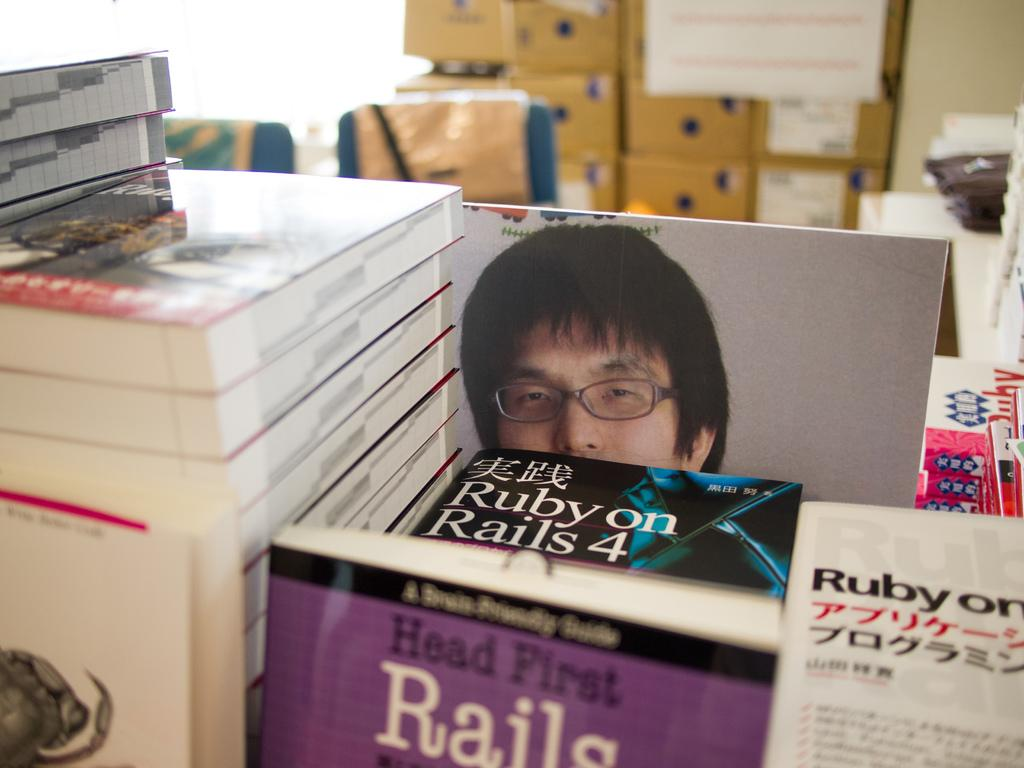What objects are present in the image? There are books, a person on a whiteboard, and cardboard boxes in the background. What can be found in the background of the image? In the background, there are cardboard boxes and two chairs. What is the person on the whiteboard doing? The provided facts do not specify what the person on the whiteboard is doing. How many roots can be seen growing from the books in the image? There are no roots visible in the image, as the image features books, a person on a whiteboard, cardboard boxes, and chairs. 